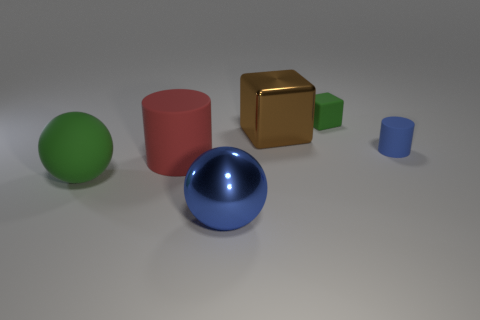Add 2 brown shiny blocks. How many objects exist? 8 Add 4 red matte things. How many red matte things exist? 5 Subtract 0 cyan blocks. How many objects are left? 6 Subtract all large matte spheres. Subtract all big rubber cylinders. How many objects are left? 4 Add 4 large blue metal things. How many large blue metal things are left? 5 